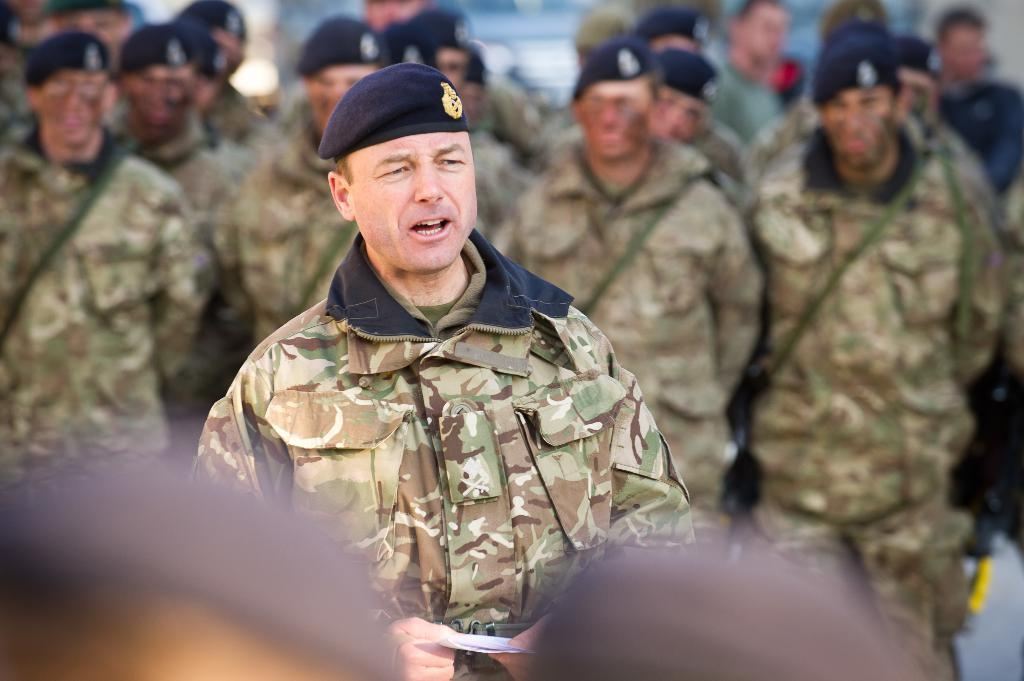How many people are in the image? There is a group of people in the image. What are the people wearing on their heads? The people are wearing caps. What is one person holding in the image? One person is holding a paper. Can you describe the background of the image? The background of the image is blurry. Is there any quicksand visible in the image? No, there is no quicksand present in the image. What is the opinion of the group of people about the topic of the paper? The image does not provide any information about the opinions of the people, as it only shows them wearing caps and holding a paper. 